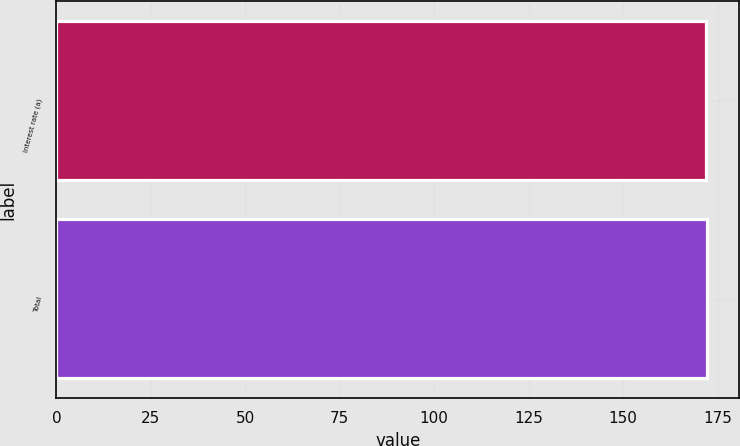Convert chart to OTSL. <chart><loc_0><loc_0><loc_500><loc_500><bar_chart><fcel>Interest rate (a)<fcel>Total<nl><fcel>172<fcel>172.1<nl></chart> 